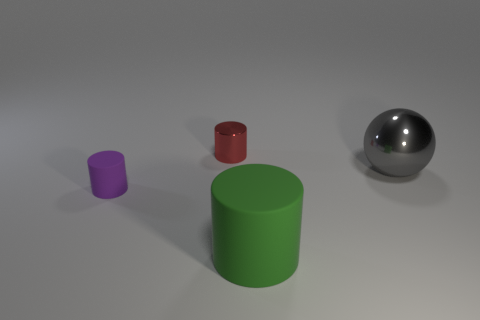Is the material of the thing that is on the right side of the big matte cylinder the same as the thing that is behind the gray sphere?
Your answer should be compact. Yes. There is a object that is right of the tiny metallic cylinder and on the left side of the large metal sphere; what shape is it?
Your answer should be very brief. Cylinder. Is there anything else that is the same material as the small red thing?
Offer a terse response. Yes. The object that is right of the small red metal object and to the left of the gray ball is made of what material?
Make the answer very short. Rubber. There is another large thing that is the same material as the purple object; what is its shape?
Keep it short and to the point. Cylinder. Are there any other things that have the same color as the big ball?
Offer a very short reply. No. Are there more big gray balls that are in front of the metal sphere than purple things?
Your response must be concise. No. What material is the red cylinder?
Your answer should be very brief. Metal. How many purple rubber cylinders have the same size as the gray metal thing?
Your answer should be compact. 0. Are there an equal number of gray things that are in front of the purple thing and small shiny cylinders in front of the green rubber object?
Your answer should be very brief. Yes. 